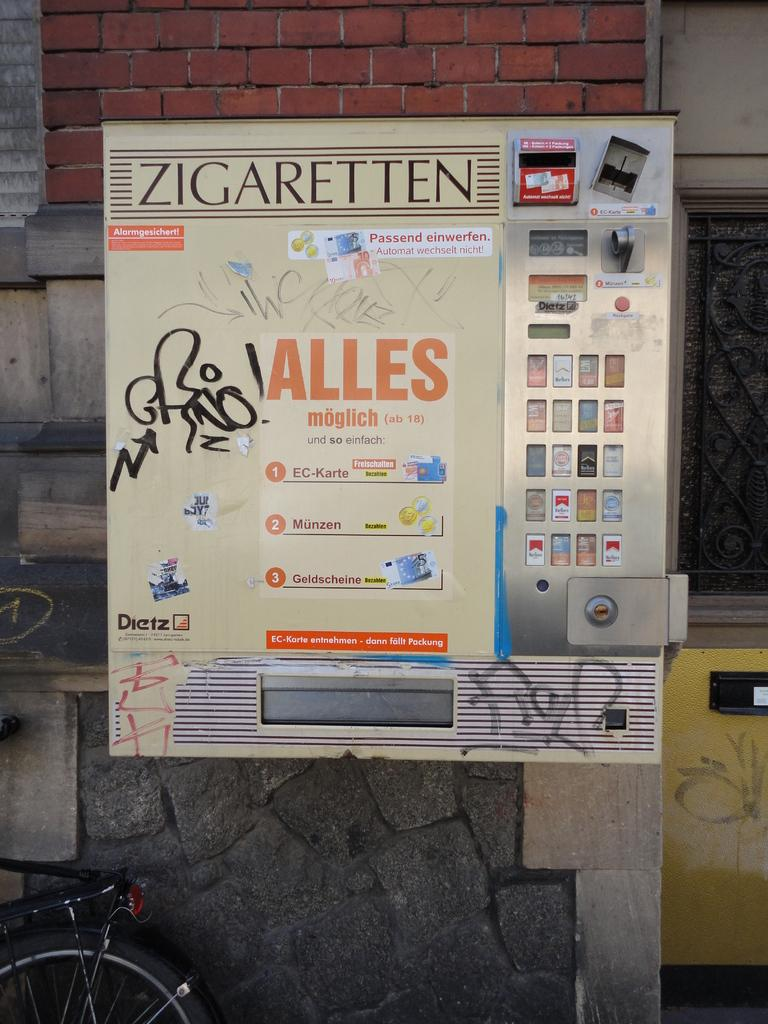<image>
Relay a brief, clear account of the picture shown. In Germany there is a vending machine for ZIGARETTEN or cigarettes. 